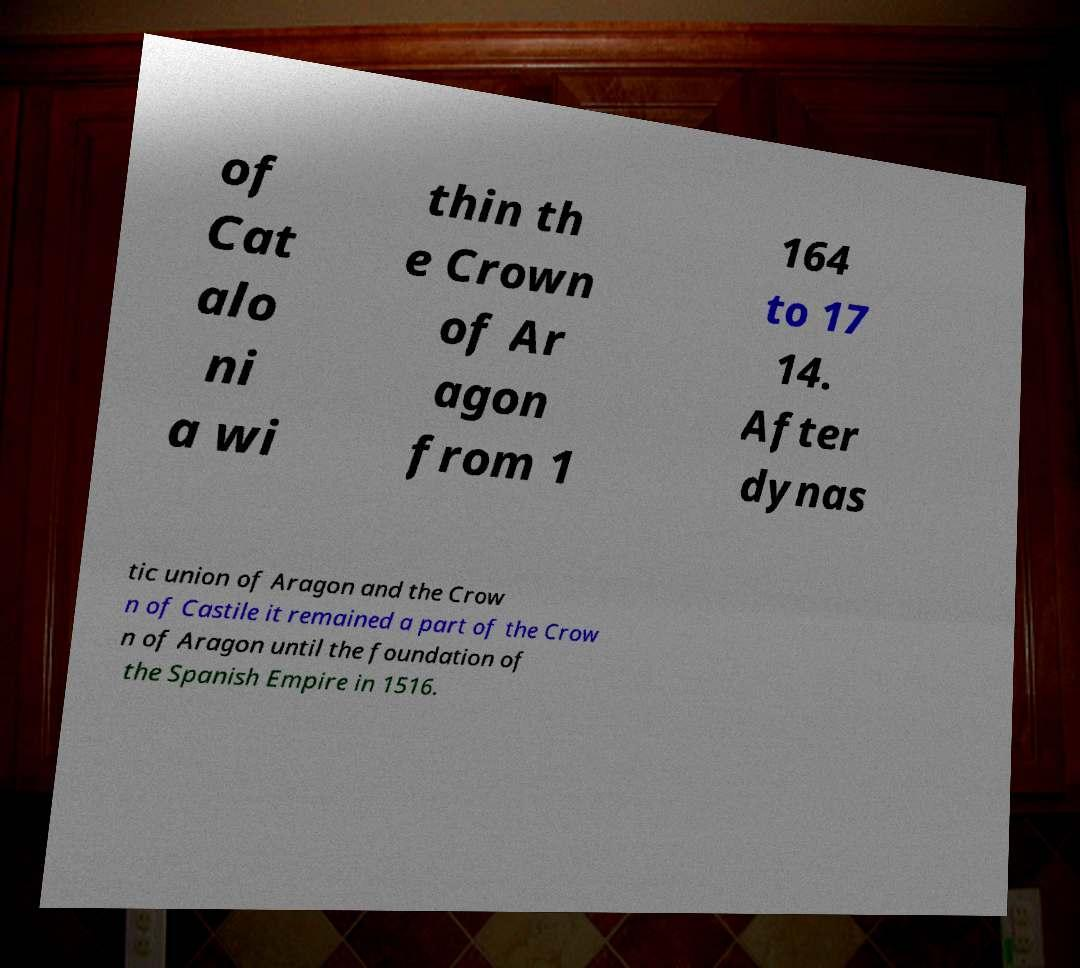Please identify and transcribe the text found in this image. of Cat alo ni a wi thin th e Crown of Ar agon from 1 164 to 17 14. After dynas tic union of Aragon and the Crow n of Castile it remained a part of the Crow n of Aragon until the foundation of the Spanish Empire in 1516. 